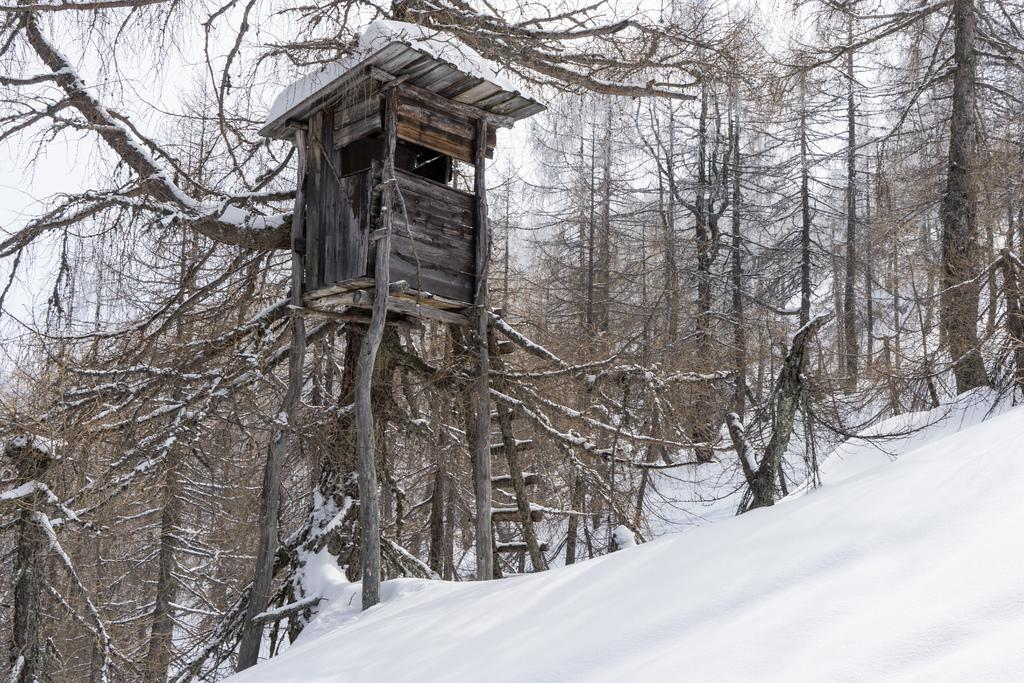What is the main feature of the landscape in the image? There is snow in the image. What type of natural elements can be seen in the image? There are trees in the image. Is there any man-made structure visible in the image? Yes, there is a tree house in the image. How can someone access the tree house? There is a ladder in the image that can be used to access the tree house. What is the condition of the trees in the image? Snow is visible on the trees. What is visible in the background of the image? The sky is visible in the background of the image. Can you see the mother pointing at the tree house in the image? There is no mother or pointing gesture visible in the image. How many times does the person kick the snow in the image? There is no person kicking snow in the image. 